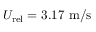Convert formula to latex. <formula><loc_0><loc_0><loc_500><loc_500>U _ { r e l } = 3 . 1 7 m / s</formula> 